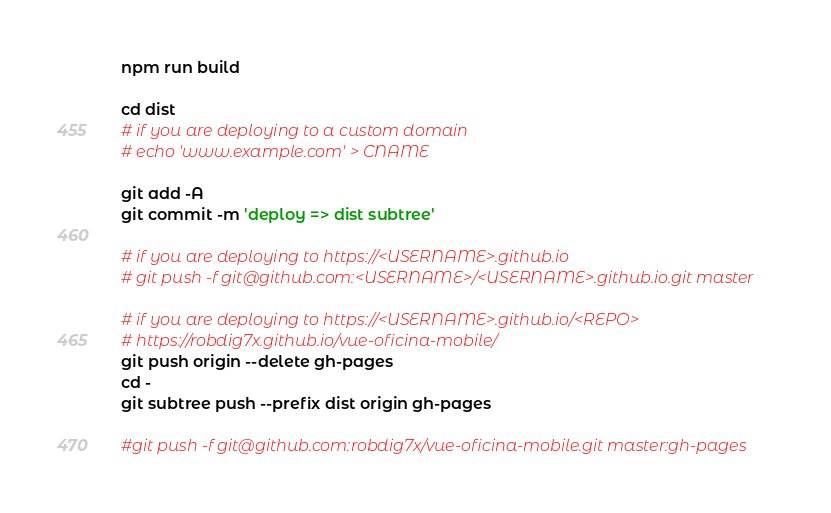<code> <loc_0><loc_0><loc_500><loc_500><_Bash_>npm run build

cd dist 
# if you are deploying to a custom domain
# echo 'www.example.com' > CNAME

git add -A
git commit -m 'deploy => dist subtree'

# if you are deploying to https://<USERNAME>.github.io
# git push -f git@github.com:<USERNAME>/<USERNAME>.github.io.git master

# if you are deploying to https://<USERNAME>.github.io/<REPO>
# https://robdig7x.github.io/vue-oficina-mobile/
git push origin --delete gh-pages
cd -
git subtree push --prefix dist origin gh-pages

#git push -f git@github.com:robdig7x/vue-oficina-mobile.git master:gh-pages

</code> 